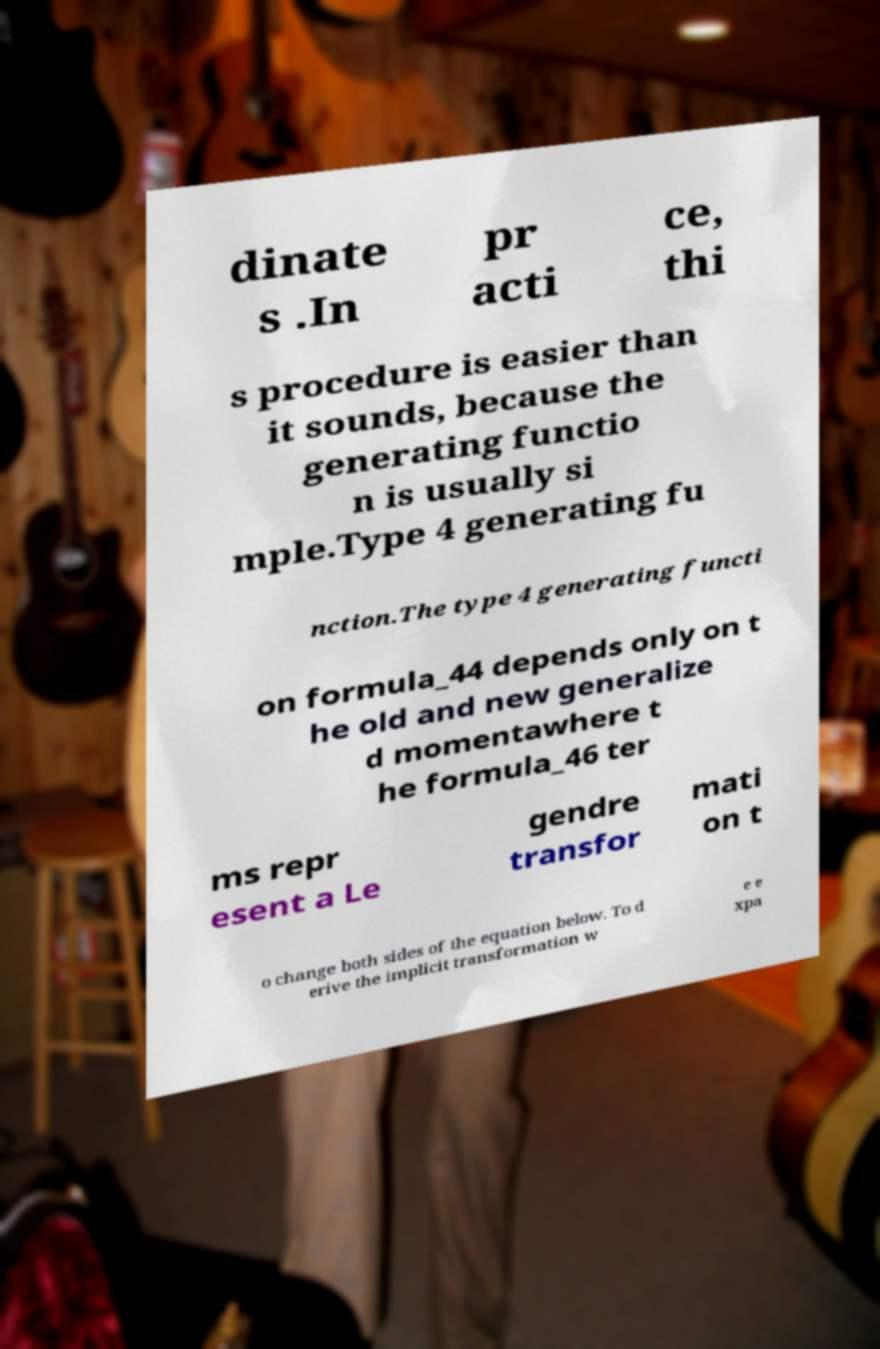Can you accurately transcribe the text from the provided image for me? dinate s .In pr acti ce, thi s procedure is easier than it sounds, because the generating functio n is usually si mple.Type 4 generating fu nction.The type 4 generating functi on formula_44 depends only on t he old and new generalize d momentawhere t he formula_46 ter ms repr esent a Le gendre transfor mati on t o change both sides of the equation below. To d erive the implicit transformation w e e xpa 